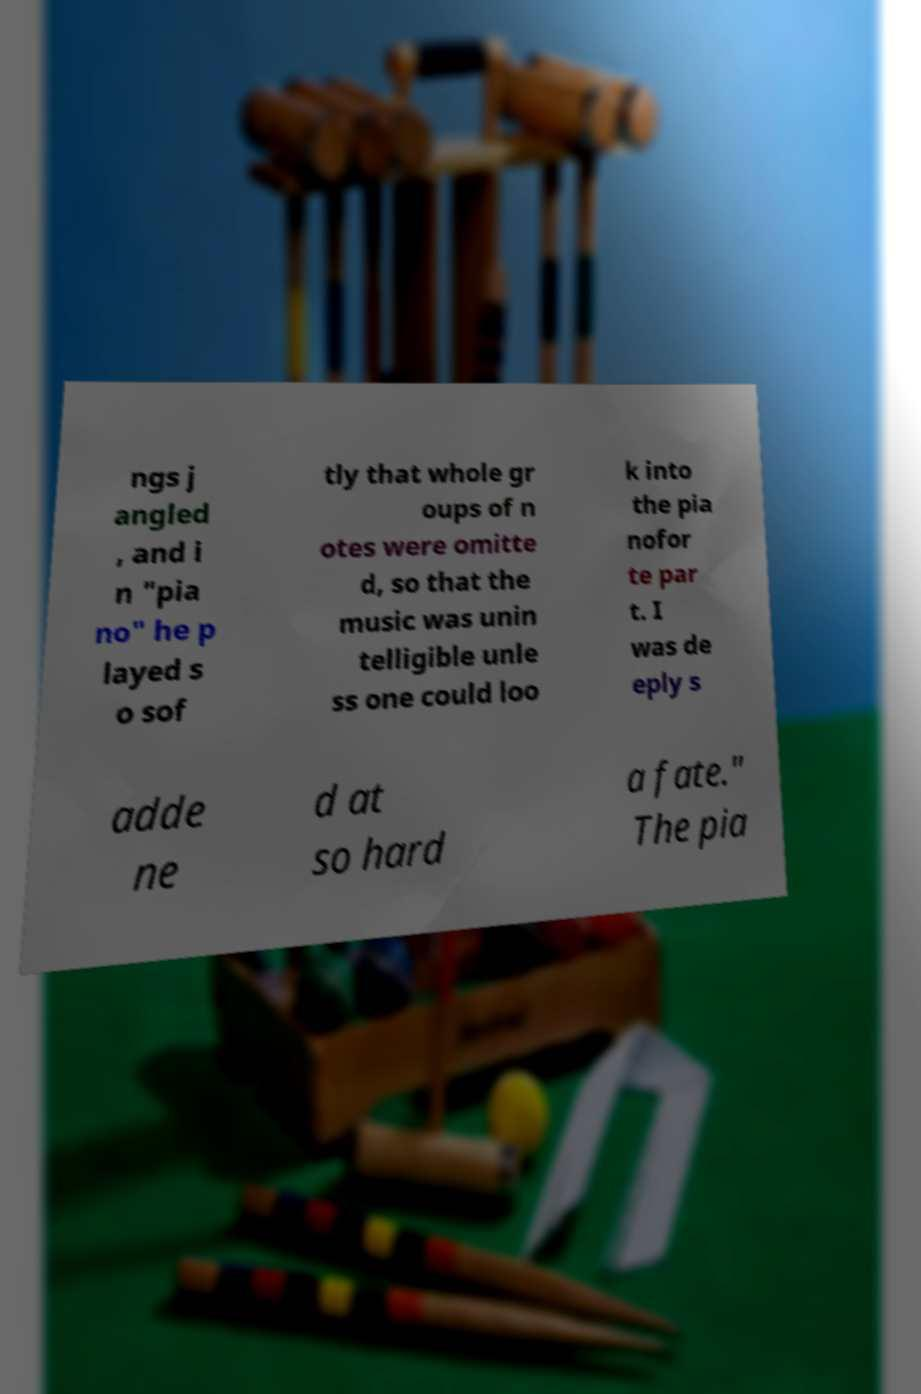Can you accurately transcribe the text from the provided image for me? ngs j angled , and i n "pia no" he p layed s o sof tly that whole gr oups of n otes were omitte d, so that the music was unin telligible unle ss one could loo k into the pia nofor te par t. I was de eply s adde ne d at so hard a fate." The pia 